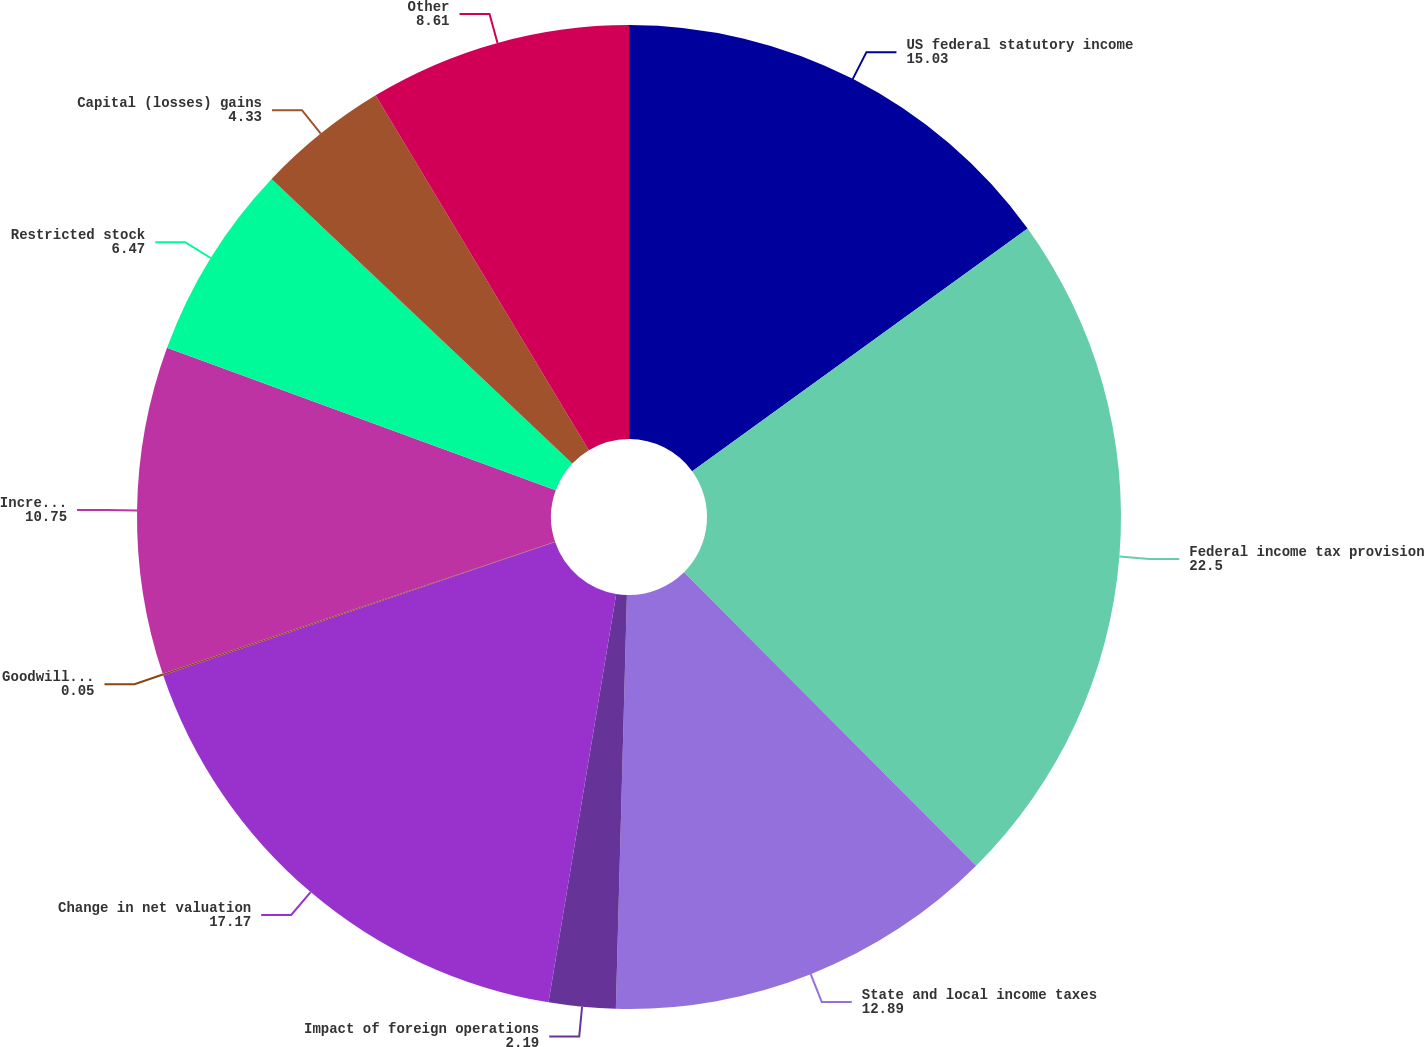Convert chart to OTSL. <chart><loc_0><loc_0><loc_500><loc_500><pie_chart><fcel>US federal statutory income<fcel>Federal income tax provision<fcel>State and local income taxes<fcel>Impact of foreign operations<fcel>Change in net valuation<fcel>Goodwill and other long-lived<fcel>Increases (decreases) in<fcel>Restricted stock<fcel>Capital (losses) gains<fcel>Other<nl><fcel>15.03%<fcel>22.5%<fcel>12.89%<fcel>2.19%<fcel>17.17%<fcel>0.05%<fcel>10.75%<fcel>6.47%<fcel>4.33%<fcel>8.61%<nl></chart> 